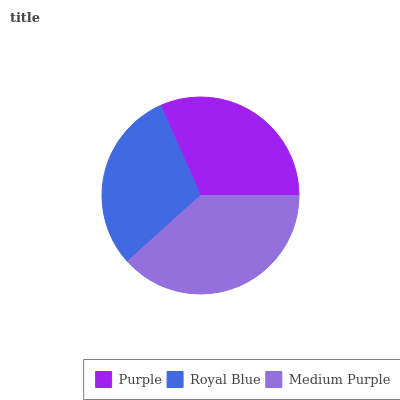Is Royal Blue the minimum?
Answer yes or no. Yes. Is Medium Purple the maximum?
Answer yes or no. Yes. Is Medium Purple the minimum?
Answer yes or no. No. Is Royal Blue the maximum?
Answer yes or no. No. Is Medium Purple greater than Royal Blue?
Answer yes or no. Yes. Is Royal Blue less than Medium Purple?
Answer yes or no. Yes. Is Royal Blue greater than Medium Purple?
Answer yes or no. No. Is Medium Purple less than Royal Blue?
Answer yes or no. No. Is Purple the high median?
Answer yes or no. Yes. Is Purple the low median?
Answer yes or no. Yes. Is Medium Purple the high median?
Answer yes or no. No. Is Medium Purple the low median?
Answer yes or no. No. 